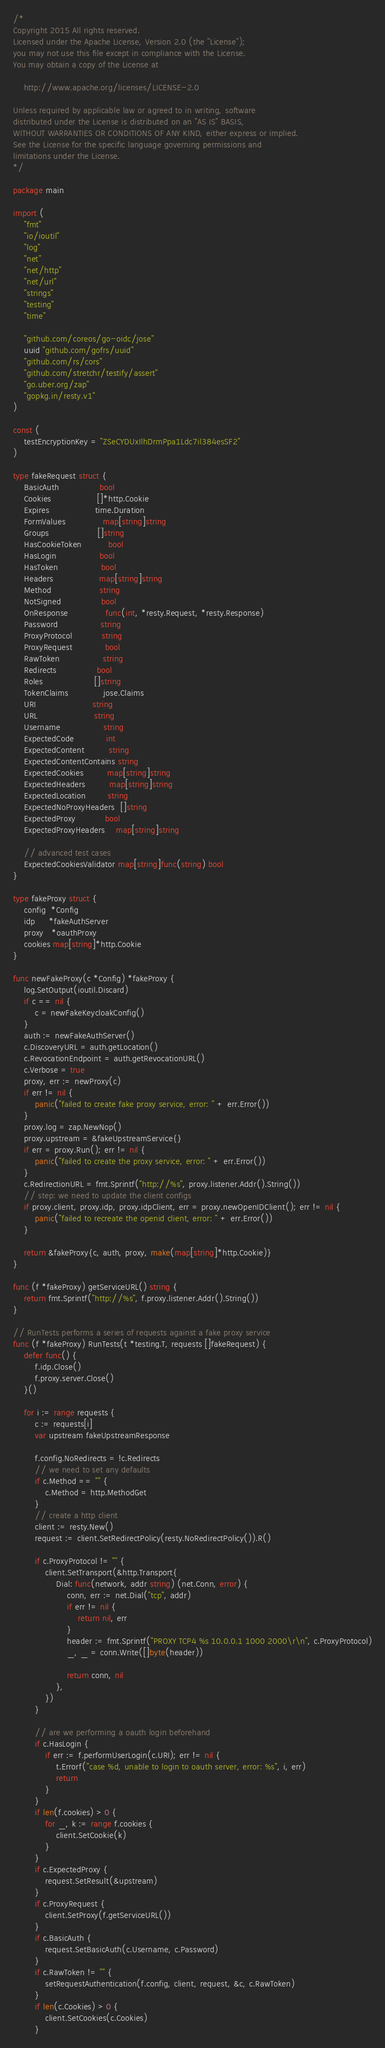<code> <loc_0><loc_0><loc_500><loc_500><_Go_>/*
Copyright 2015 All rights reserved.
Licensed under the Apache License, Version 2.0 (the "License");
you may not use this file except in compliance with the License.
You may obtain a copy of the License at

    http://www.apache.org/licenses/LICENSE-2.0

Unless required by applicable law or agreed to in writing, software
distributed under the License is distributed on an "AS IS" BASIS,
WITHOUT WARRANTIES OR CONDITIONS OF ANY KIND, either express or implied.
See the License for the specific language governing permissions and
limitations under the License.
*/

package main

import (
	"fmt"
	"io/ioutil"
	"log"
	"net"
	"net/http"
	"net/url"
	"strings"
	"testing"
	"time"

	"github.com/coreos/go-oidc/jose"
	uuid "github.com/gofrs/uuid"
	"github.com/rs/cors"
	"github.com/stretchr/testify/assert"
	"go.uber.org/zap"
	"gopkg.in/resty.v1"
)

const (
	testEncryptionKey = "ZSeCYDUxIlhDrmPpa1Ldc7il384esSF2"
)

type fakeRequest struct {
	BasicAuth               bool
	Cookies                 []*http.Cookie
	Expires                 time.Duration
	FormValues              map[string]string
	Groups                  []string
	HasCookieToken          bool
	HasLogin                bool
	HasToken                bool
	Headers                 map[string]string
	Method                  string
	NotSigned               bool
	OnResponse              func(int, *resty.Request, *resty.Response)
	Password                string
	ProxyProtocol           string
	ProxyRequest            bool
	RawToken                string
	Redirects               bool
	Roles                   []string
	TokenClaims             jose.Claims
	URI                     string
	URL                     string
	Username                string
	ExpectedCode            int
	ExpectedContent         string
	ExpectedContentContains string
	ExpectedCookies         map[string]string
	ExpectedHeaders         map[string]string
	ExpectedLocation        string
	ExpectedNoProxyHeaders  []string
	ExpectedProxy           bool
	ExpectedProxyHeaders    map[string]string

	// advanced test cases
	ExpectedCookiesValidator map[string]func(string) bool
}

type fakeProxy struct {
	config  *Config
	idp     *fakeAuthServer
	proxy   *oauthProxy
	cookies map[string]*http.Cookie
}

func newFakeProxy(c *Config) *fakeProxy {
	log.SetOutput(ioutil.Discard)
	if c == nil {
		c = newFakeKeycloakConfig()
	}
	auth := newFakeAuthServer()
	c.DiscoveryURL = auth.getLocation()
	c.RevocationEndpoint = auth.getRevocationURL()
	c.Verbose = true
	proxy, err := newProxy(c)
	if err != nil {
		panic("failed to create fake proxy service, error: " + err.Error())
	}
	proxy.log = zap.NewNop()
	proxy.upstream = &fakeUpstreamService{}
	if err = proxy.Run(); err != nil {
		panic("failed to create the proxy service, error: " + err.Error())
	}
	c.RedirectionURL = fmt.Sprintf("http://%s", proxy.listener.Addr().String())
	// step: we need to update the client configs
	if proxy.client, proxy.idp, proxy.idpClient, err = proxy.newOpenIDClient(); err != nil {
		panic("failed to recreate the openid client, error: " + err.Error())
	}

	return &fakeProxy{c, auth, proxy, make(map[string]*http.Cookie)}
}

func (f *fakeProxy) getServiceURL() string {
	return fmt.Sprintf("http://%s", f.proxy.listener.Addr().String())
}

// RunTests performs a series of requests against a fake proxy service
func (f *fakeProxy) RunTests(t *testing.T, requests []fakeRequest) {
	defer func() {
		f.idp.Close()
		f.proxy.server.Close()
	}()

	for i := range requests {
		c := requests[i]
		var upstream fakeUpstreamResponse

		f.config.NoRedirects = !c.Redirects
		// we need to set any defaults
		if c.Method == "" {
			c.Method = http.MethodGet
		}
		// create a http client
		client := resty.New()
		request := client.SetRedirectPolicy(resty.NoRedirectPolicy()).R()

		if c.ProxyProtocol != "" {
			client.SetTransport(&http.Transport{
				Dial: func(network, addr string) (net.Conn, error) {
					conn, err := net.Dial("tcp", addr)
					if err != nil {
						return nil, err
					}
					header := fmt.Sprintf("PROXY TCP4 %s 10.0.0.1 1000 2000\r\n", c.ProxyProtocol)
					_, _ = conn.Write([]byte(header))

					return conn, nil
				},
			})
		}

		// are we performing a oauth login beforehand
		if c.HasLogin {
			if err := f.performUserLogin(c.URI); err != nil {
				t.Errorf("case %d, unable to login to oauth server, error: %s", i, err)
				return
			}
		}
		if len(f.cookies) > 0 {
			for _, k := range f.cookies {
				client.SetCookie(k)
			}
		}
		if c.ExpectedProxy {
			request.SetResult(&upstream)
		}
		if c.ProxyRequest {
			client.SetProxy(f.getServiceURL())
		}
		if c.BasicAuth {
			request.SetBasicAuth(c.Username, c.Password)
		}
		if c.RawToken != "" {
			setRequestAuthentication(f.config, client, request, &c, c.RawToken)
		}
		if len(c.Cookies) > 0 {
			client.SetCookies(c.Cookies)
		}</code> 